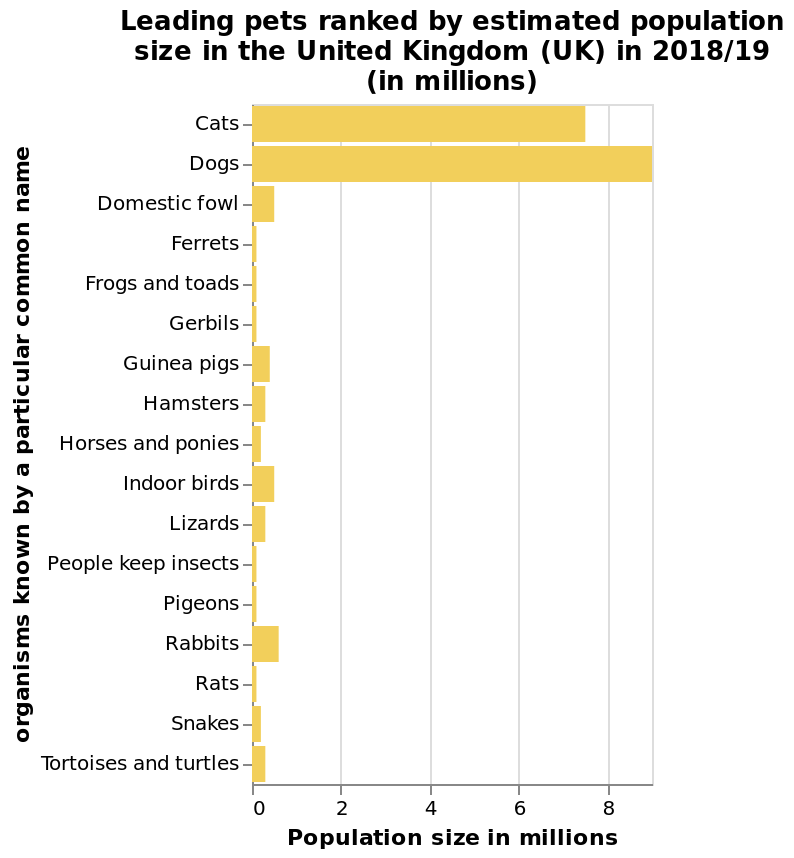<image>
What was the most common pet in the UK in 2018/19? Dogs were the most common pet in the UK in 2018/19. Which animal was the second most popular pet in the UK in 2018/19? Cats were the second most popular pet in the UK in 2018/19. Offer a thorough analysis of the image. In 2018/19, dogs were the most common pet in the UK. Cats were the second most popular pet in the UK in 2018/19. What is the title of the graph?  The graph is titled "Leading pets ranked by estimated population size in the United Kingdom (UK) in 2018/19". Among the UK population, what was the ranking of cats as a pet in 2018/19? Cats were ranked second among the UK population as pets in 2018/19. 